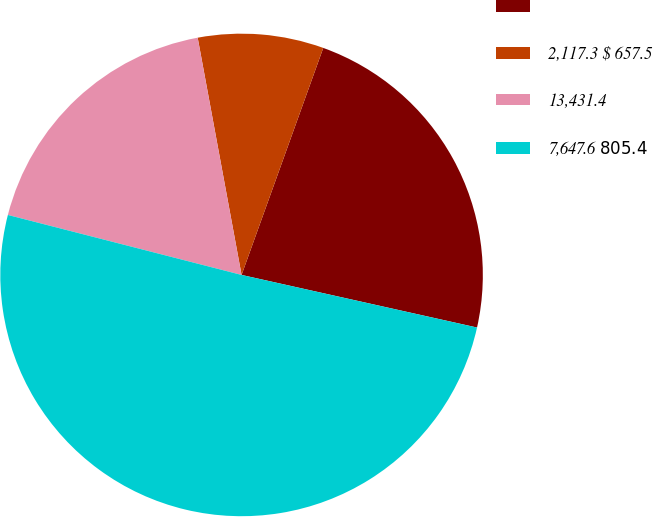Convert chart. <chart><loc_0><loc_0><loc_500><loc_500><pie_chart><ecel><fcel>2,117.3 $ 657.5<fcel>13,431.4<fcel>7,647.6 $ 805.4 $<nl><fcel>23.0%<fcel>8.41%<fcel>18.09%<fcel>50.5%<nl></chart> 